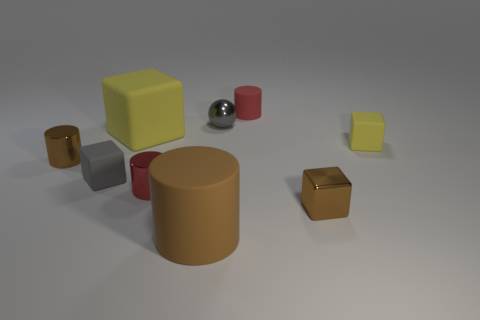The small object that is the same color as the small ball is what shape?
Your answer should be compact. Cube. How many other things are the same material as the tiny yellow object?
Your answer should be very brief. 4. What is the size of the brown rubber cylinder?
Offer a terse response. Large. Are there any big purple objects of the same shape as the large yellow thing?
Make the answer very short. No. What number of things are either small blue shiny balls or small rubber cubes to the left of the big matte cylinder?
Keep it short and to the point. 1. There is a tiny matte thing that is behind the ball; what is its color?
Your answer should be very brief. Red. There is a red thing that is on the left side of the red matte cylinder; is its size the same as the gray object that is in front of the large yellow block?
Keep it short and to the point. Yes. Are there any other brown shiny cylinders of the same size as the brown metal cylinder?
Provide a succinct answer. No. How many tiny gray balls are in front of the big object in front of the small gray rubber thing?
Give a very brief answer. 0. What is the material of the gray ball?
Your answer should be very brief. Metal. 